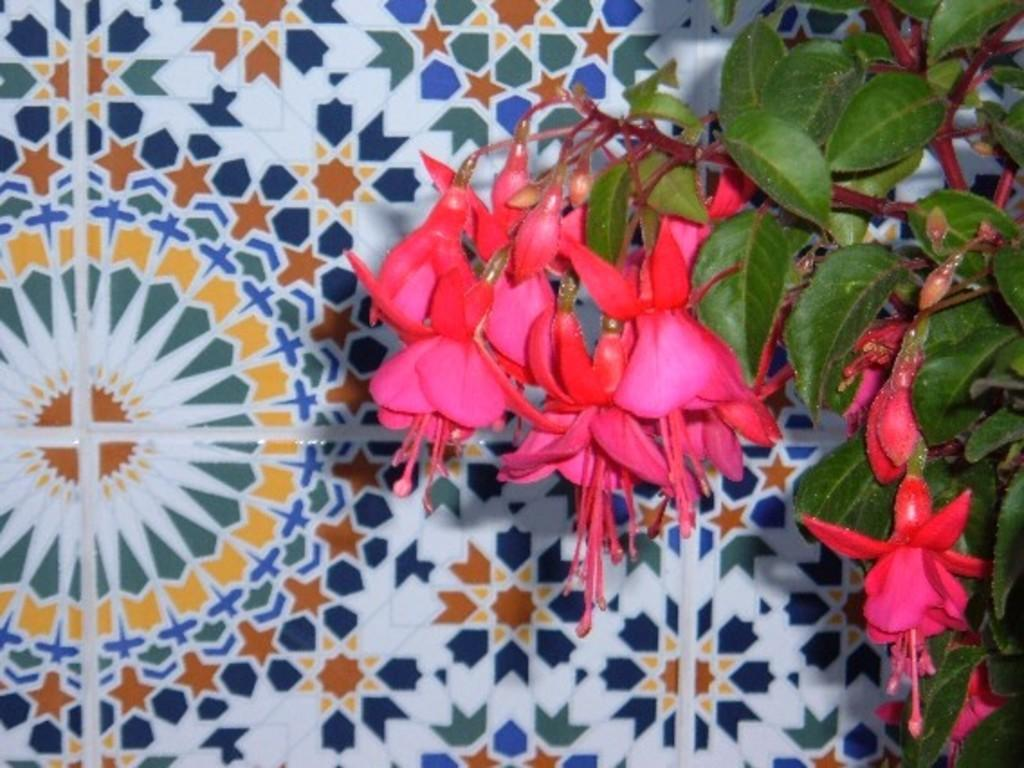What type of plant can be seen in the image? There is a flower in the image. What else is present on the plant besides the flower? There are leaves in the image. What can be seen in the background of the image? There is a surface visible in the background of the image. What type of prison can be seen in the image? There is no prison present in the image; it features a flower and leaves. How does the flower contribute to harmony in the image? The image does not depict harmony or any related concepts; it simply shows a flower and leaves. 